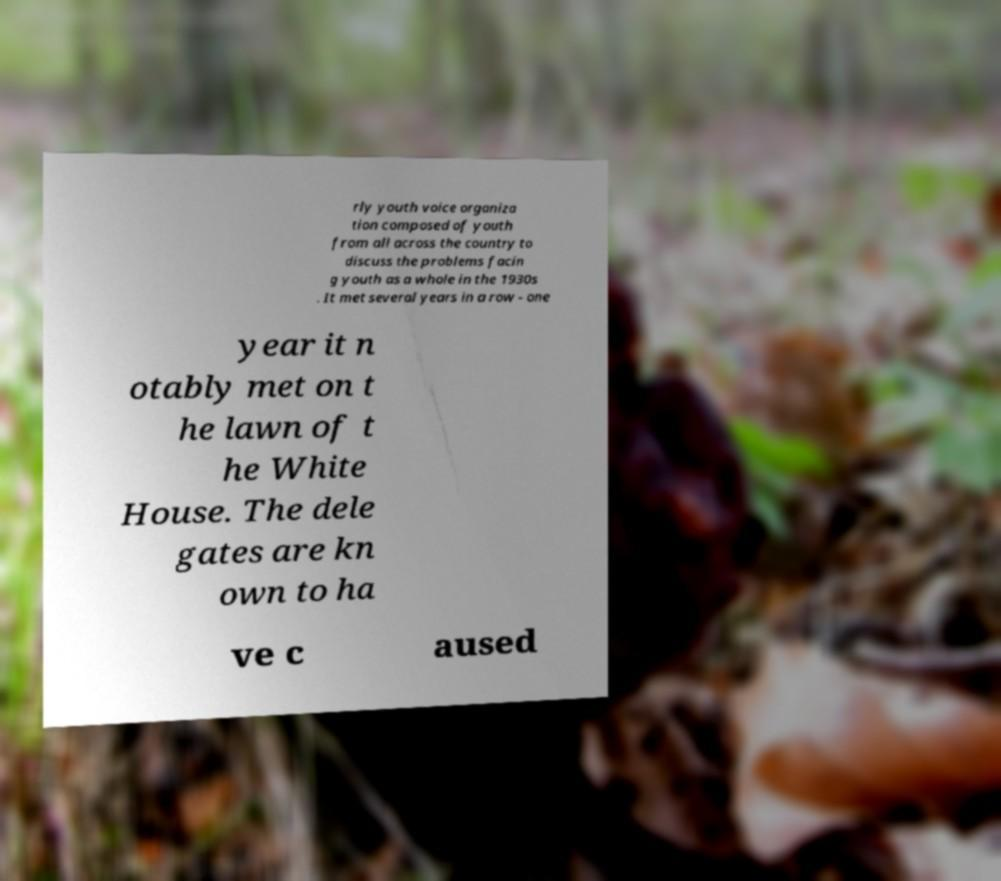Please identify and transcribe the text found in this image. rly youth voice organiza tion composed of youth from all across the country to discuss the problems facin g youth as a whole in the 1930s . It met several years in a row - one year it n otably met on t he lawn of t he White House. The dele gates are kn own to ha ve c aused 